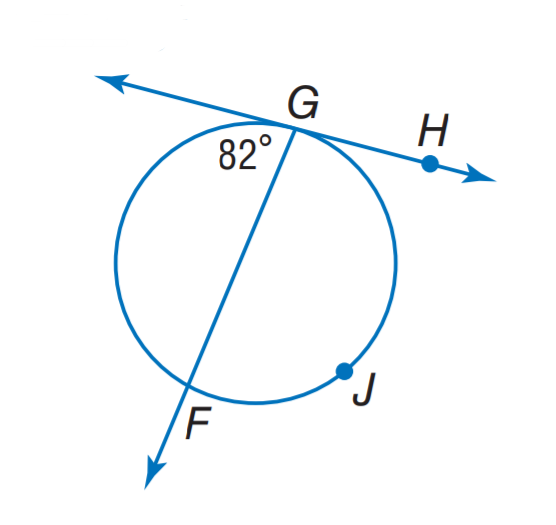Question: Find m \widehat G J F.
Choices:
A. 82
B. 164
C. 196
D. 216
Answer with the letter. Answer: C 